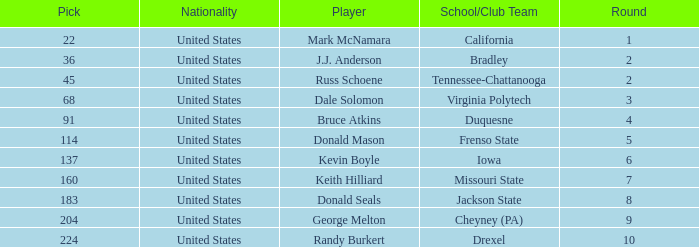What is the earliest round that Donald Mason had a pick larger than 114? None. 